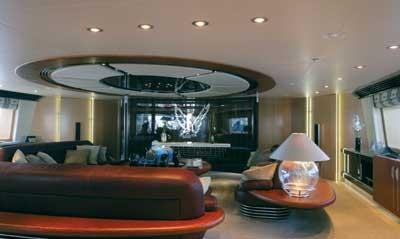Is this some sort of craft idea?
Keep it brief. No. Is the television on?
Answer briefly. Yes. Is this a hotel lobby?
Short answer required. Yes. Is the room lit?
Be succinct. Yes. 